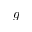Convert formula to latex. <formula><loc_0><loc_0><loc_500><loc_500>g</formula> 